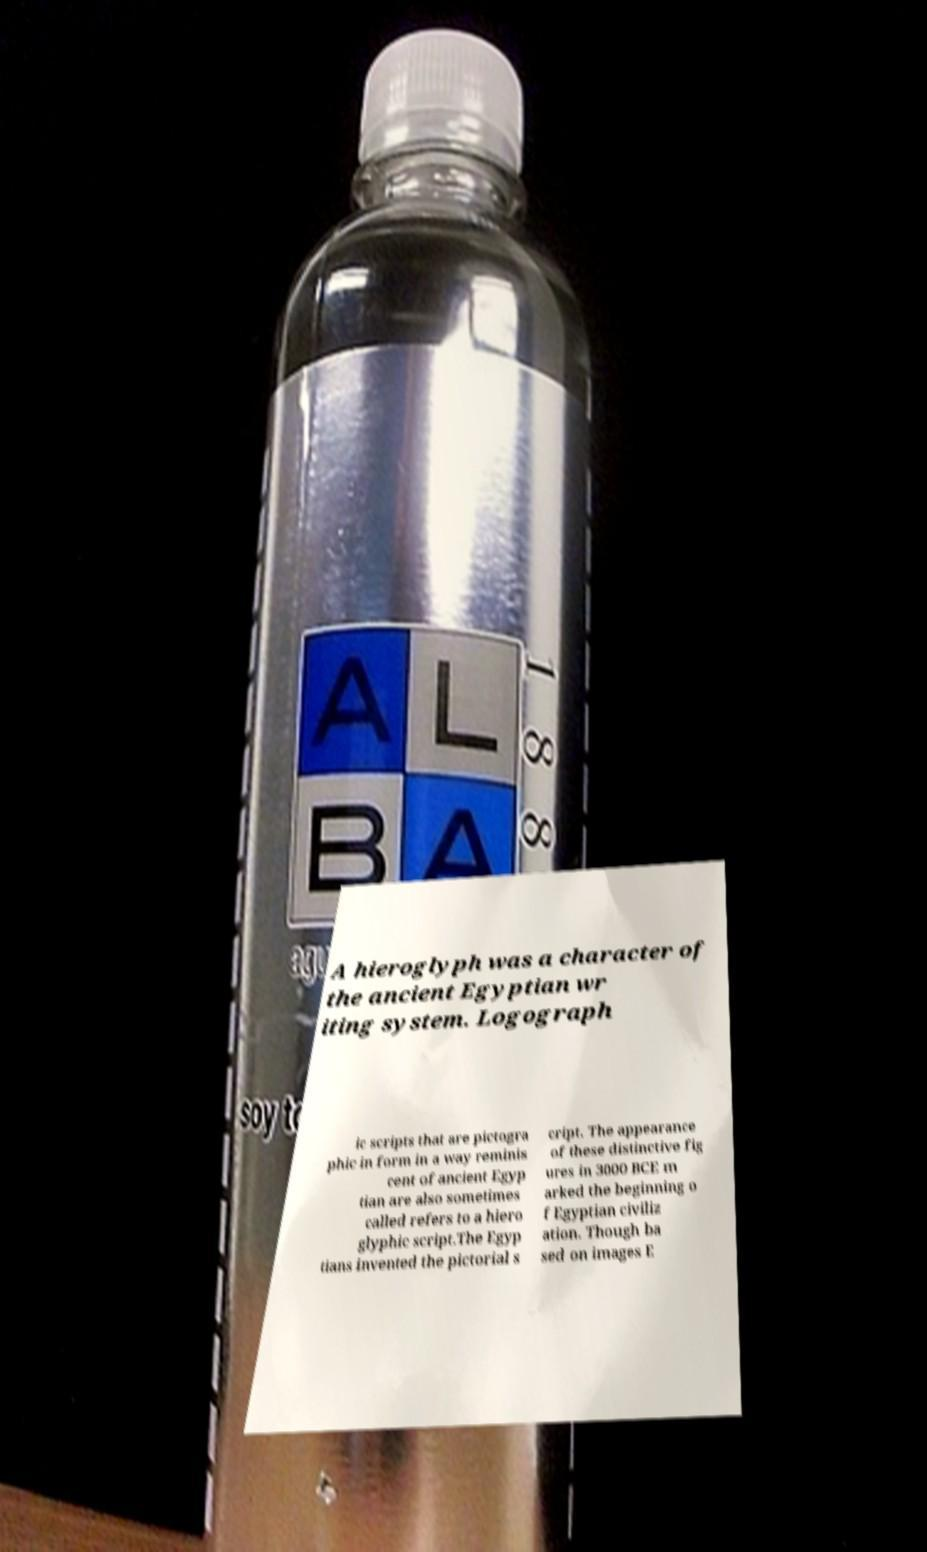There's text embedded in this image that I need extracted. Can you transcribe it verbatim? A hieroglyph was a character of the ancient Egyptian wr iting system. Logograph ic scripts that are pictogra phic in form in a way reminis cent of ancient Egyp tian are also sometimes called refers to a hiero glyphic script.The Egyp tians invented the pictorial s cript. The appearance of these distinctive fig ures in 3000 BCE m arked the beginning o f Egyptian civiliz ation. Though ba sed on images E 